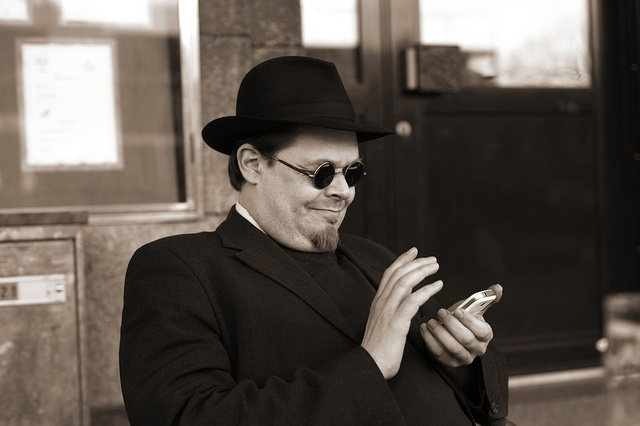Describe the objects in this image and their specific colors. I can see people in white, black, darkgray, and gray tones and cell phone in white, darkgray, and gray tones in this image. 